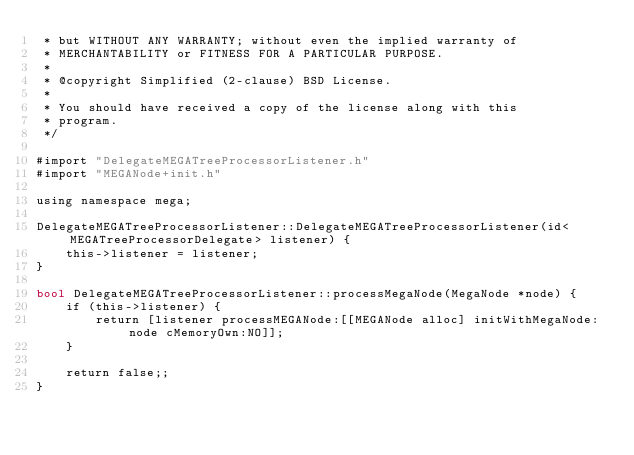<code> <loc_0><loc_0><loc_500><loc_500><_ObjectiveC_> * but WITHOUT ANY WARRANTY; without even the implied warranty of
 * MERCHANTABILITY or FITNESS FOR A PARTICULAR PURPOSE.
 *
 * @copyright Simplified (2-clause) BSD License.
 *
 * You should have received a copy of the license along with this
 * program.
 */

#import "DelegateMEGATreeProcessorListener.h"
#import "MEGANode+init.h"

using namespace mega;

DelegateMEGATreeProcessorListener::DelegateMEGATreeProcessorListener(id<MEGATreeProcessorDelegate> listener) {
    this->listener = listener;
}

bool DelegateMEGATreeProcessorListener::processMegaNode(MegaNode *node) {
    if (this->listener) {
        return [listener processMEGANode:[[MEGANode alloc] initWithMegaNode:node cMemoryOwn:NO]];
    }
    
    return false;;
}
</code> 